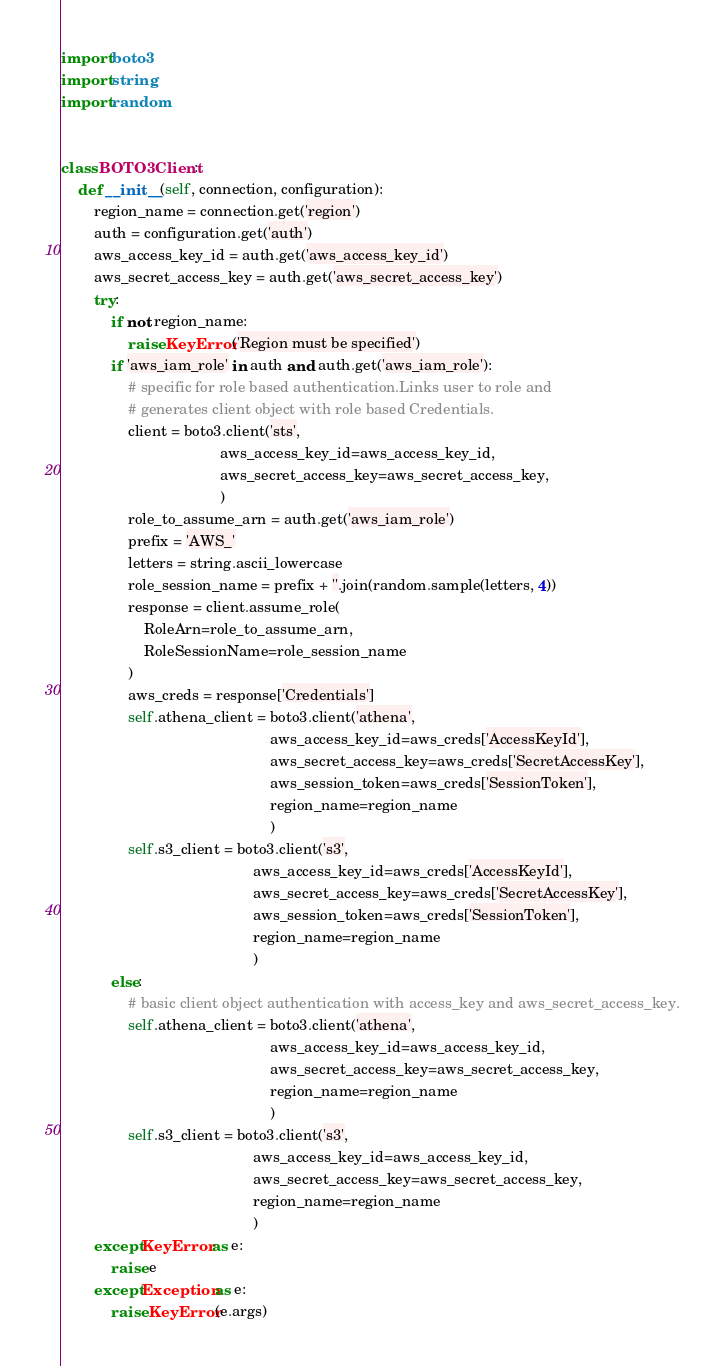Convert code to text. <code><loc_0><loc_0><loc_500><loc_500><_Python_>import boto3
import string
import random


class BOTO3Client:
    def __init__(self, connection, configuration):
        region_name = connection.get('region')
        auth = configuration.get('auth')
        aws_access_key_id = auth.get('aws_access_key_id')
        aws_secret_access_key = auth.get('aws_secret_access_key')
        try:
            if not region_name:
                raise KeyError('Region must be specified')
            if 'aws_iam_role' in auth and auth.get('aws_iam_role'):
                # specific for role based authentication.Links user to role and
                # generates client object with role based Credentials.
                client = boto3.client('sts',
                                      aws_access_key_id=aws_access_key_id,
                                      aws_secret_access_key=aws_secret_access_key,
                                      )
                role_to_assume_arn = auth.get('aws_iam_role')
                prefix = 'AWS_'
                letters = string.ascii_lowercase
                role_session_name = prefix + ''.join(random.sample(letters, 4))
                response = client.assume_role(
                    RoleArn=role_to_assume_arn,
                    RoleSessionName=role_session_name
                )
                aws_creds = response['Credentials']
                self.athena_client = boto3.client('athena',
                                                  aws_access_key_id=aws_creds['AccessKeyId'],
                                                  aws_secret_access_key=aws_creds['SecretAccessKey'],
                                                  aws_session_token=aws_creds['SessionToken'],
                                                  region_name=region_name
                                                  )
                self.s3_client = boto3.client('s3',
                                              aws_access_key_id=aws_creds['AccessKeyId'],
                                              aws_secret_access_key=aws_creds['SecretAccessKey'],
                                              aws_session_token=aws_creds['SessionToken'],
                                              region_name=region_name
                                              )
            else:
                # basic client object authentication with access_key and aws_secret_access_key.
                self.athena_client = boto3.client('athena',
                                                  aws_access_key_id=aws_access_key_id,
                                                  aws_secret_access_key=aws_secret_access_key,
                                                  region_name=region_name
                                                  )
                self.s3_client = boto3.client('s3',
                                              aws_access_key_id=aws_access_key_id,
                                              aws_secret_access_key=aws_secret_access_key,
                                              region_name=region_name
                                              )
        except KeyError as e:
            raise e
        except Exception as e:
            raise KeyError(e.args)
</code> 